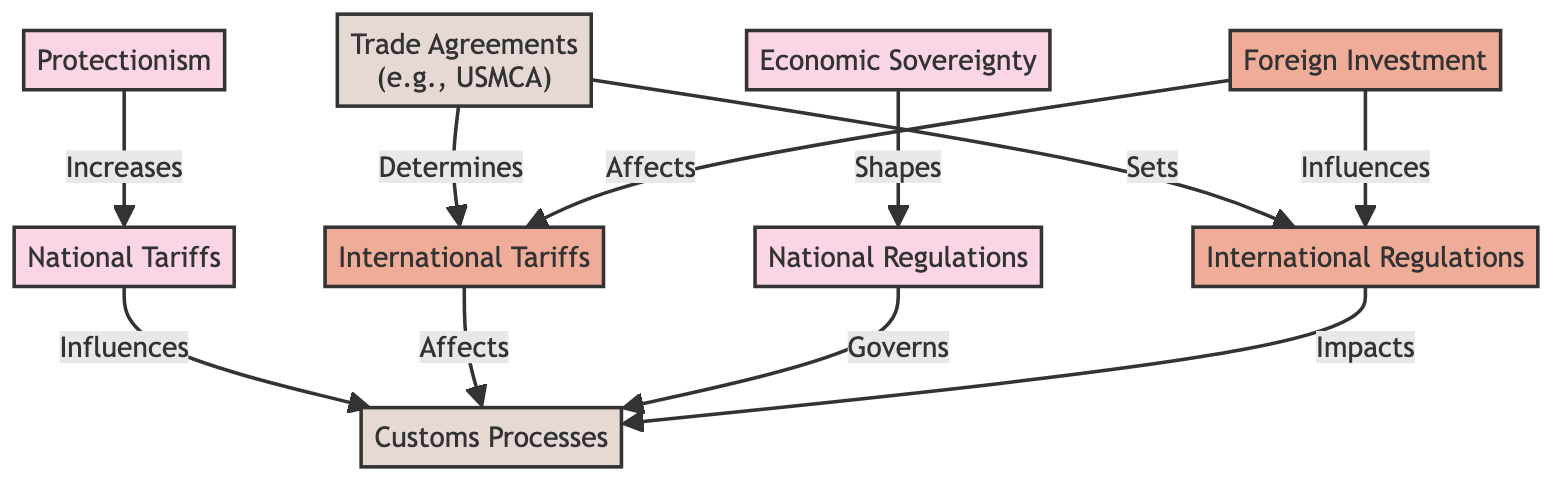What are the two types of tariffs shown in the diagram? The diagram displays two types of tariffs: 'National Tariffs' and 'International Tariffs'. These are identified as separate nodes in the graph.
Answer: National Tariffs, International Tariffs How many edges connect to the 'Customs Processes' node? The 'Customs Processes' node has four edges connecting to it, originating from 'National Tariffs', 'International Tariffs', 'National Regulations', and 'International Regulations'.
Answer: 4 Which node influences 'International Tariffs'? The 'Trade Agreements' node influences 'International Tariffs' as indicated by the directed edge connecting them.
Answer: Trade Agreements What is the relationship between 'Economic Sovereignty' and 'National Regulations'? 'Economic Sovereignty' shapes 'National Regulations', as denoted by the directed edge from 'Economic Sovereignty' to 'National Regulations'.
Answer: Shapes Which type of investment impacts both 'International Regulations' and 'International Tariffs'? 'Foreign Investment' impacts both 'International Regulations' and 'International Tariffs', which can be seen by examining the directed edges leading from 'Foreign Investment' to those nodes.
Answer: Foreign Investment What effect does 'Protectionism' have on 'National Tariffs'? 'Protectionism' increases 'National Tariffs', as indicated by the edge connecting these two nodes in the diagram.
Answer: Increases How does 'Trade Agreements' relate to the 'International Regulations'? 'Trade Agreements' sets 'International Regulations', which is displayed through the arrow pointing from 'Trade Agreements' to 'International Regulations'.
Answer: Sets Are 'National Regulations' and 'International Tariffs' directly connected? No, 'National Regulations' is not directly connected to 'International Tariffs'; there is no edge connecting these two nodes.
Answer: No 